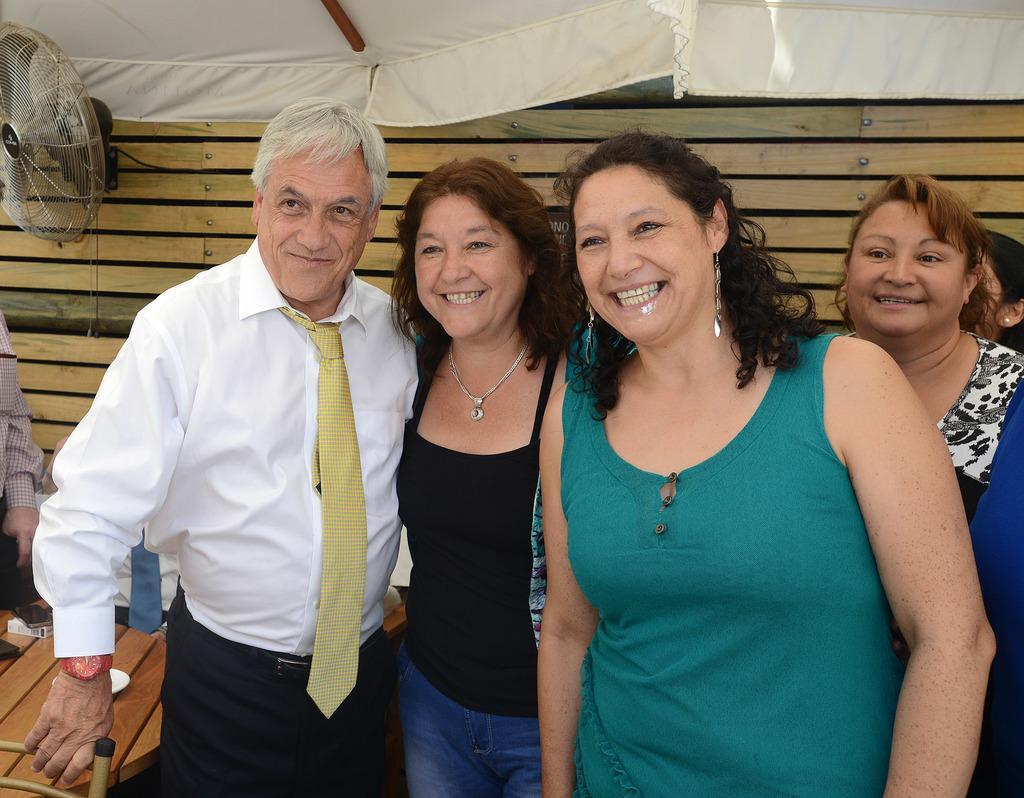Can you describe this image briefly? In this image we can see the people standing near the table, on the table we can see few objects. In the background, we can see a table fan attached to the wall. At the top we can see a tent. 